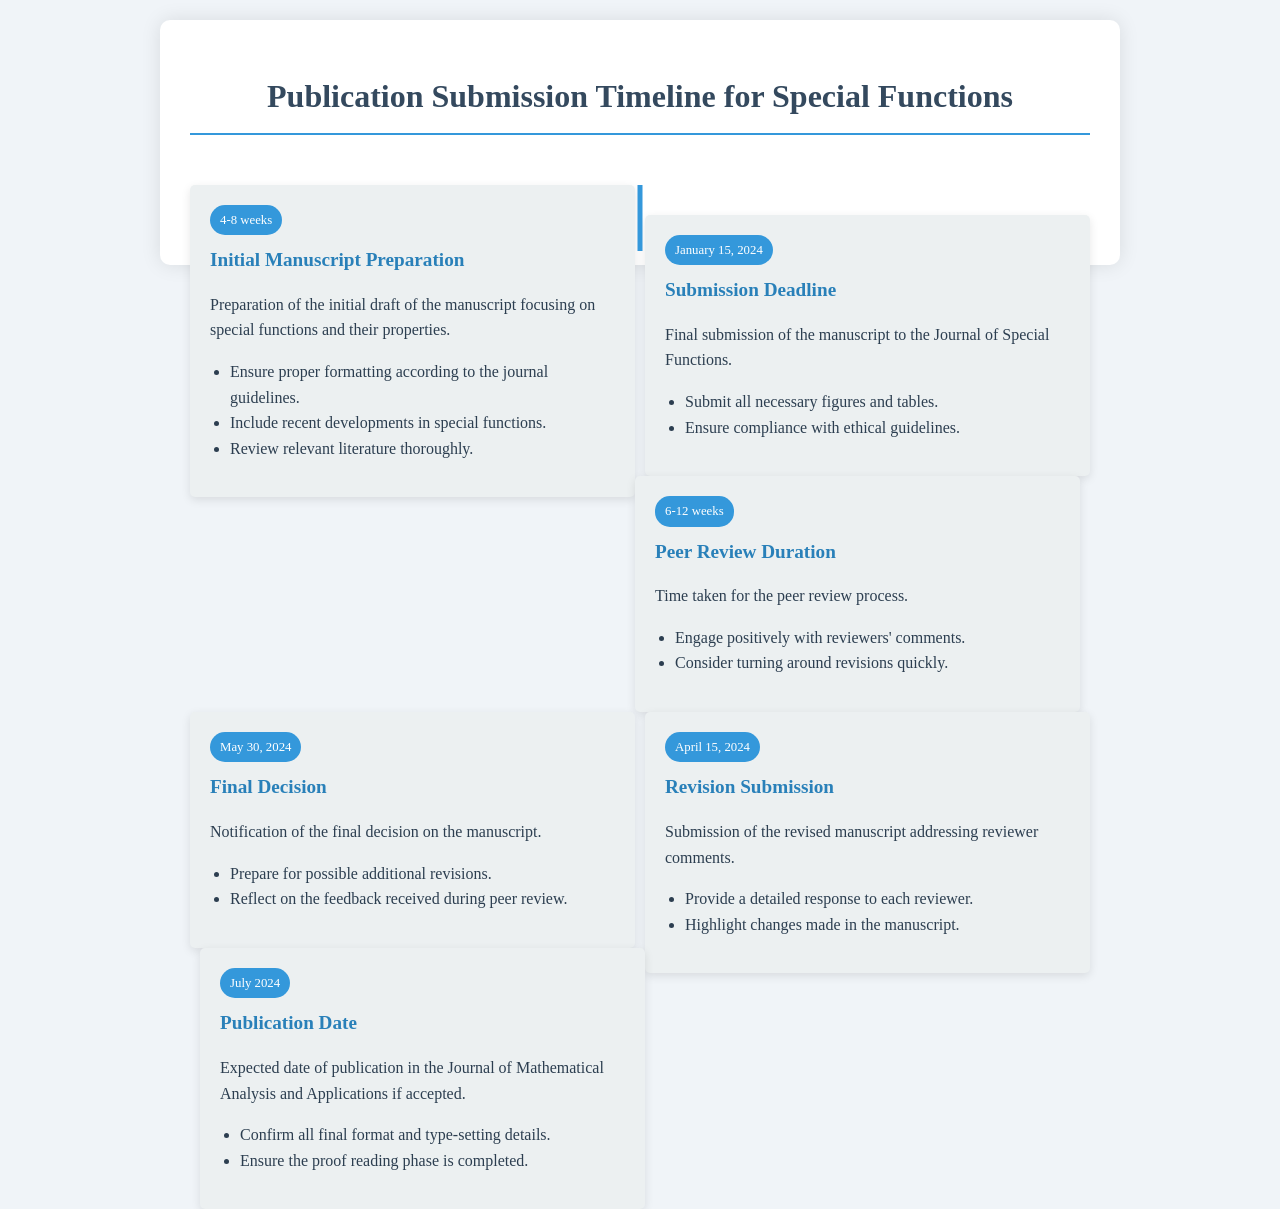what is the initial manuscript preparation duration? The document states that the duration for initial manuscript preparation is 4-8 weeks.
Answer: 4-8 weeks when is the submission deadline? The document specifies that the submission deadline is January 15, 2024.
Answer: January 15, 2024 what is the expected peer review duration? The document indicates that the peer review duration is 6-12 weeks.
Answer: 6-12 weeks when is the revision submission deadline? The document mentions that the revision submission deadline is April 15, 2024.
Answer: April 15, 2024 what is the final decision date? According to the document, the final decision date is May 30, 2024.
Answer: May 30, 2024 what should be included in the initial manuscript? The document advises including proper formatting, recent developments, and thorough literature review in the manuscript.
Answer: Proper formatting, recent developments, thorough literature review what actions should be taken during the peer review process? The document states to engage positively with reviewers' comments and consider quick revisions.
Answer: Engage positively, quick revisions what is the expected publication date? The document predicts the expected publication date is July 2024.
Answer: July 2024 